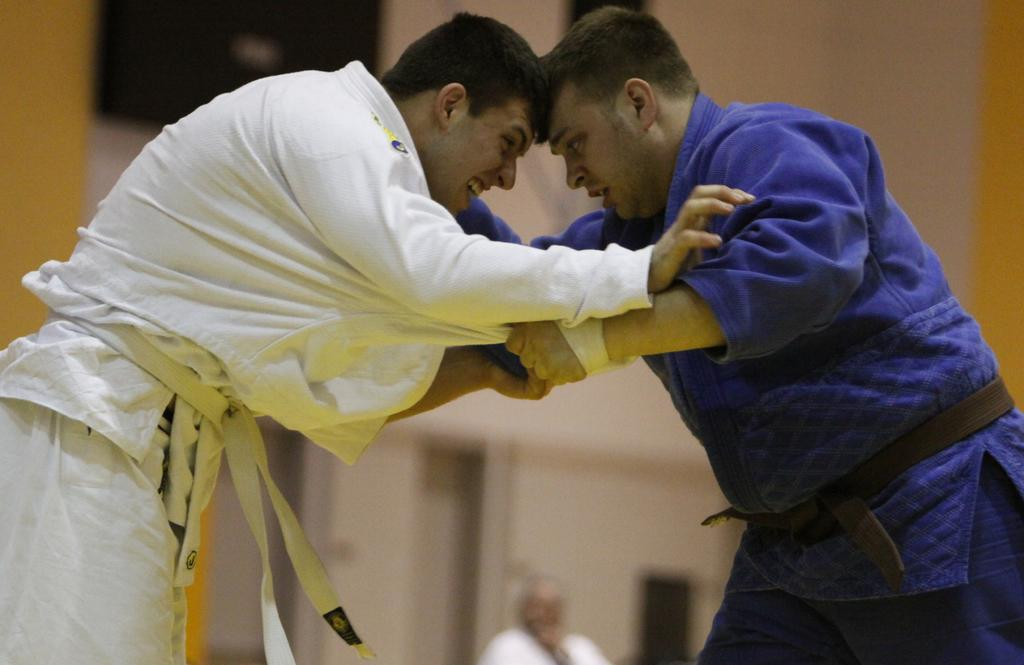How many people are in the image? There are two persons in the image. What are the two persons doing in the image? The two persons are fighting with each other. What can be seen in the background of the image? There is a wall and other objects in the background of the image. What type of ink can be seen dripping from the airplane in the image? There is no airplane present in the image, so there is no ink dripping from an airplane. 